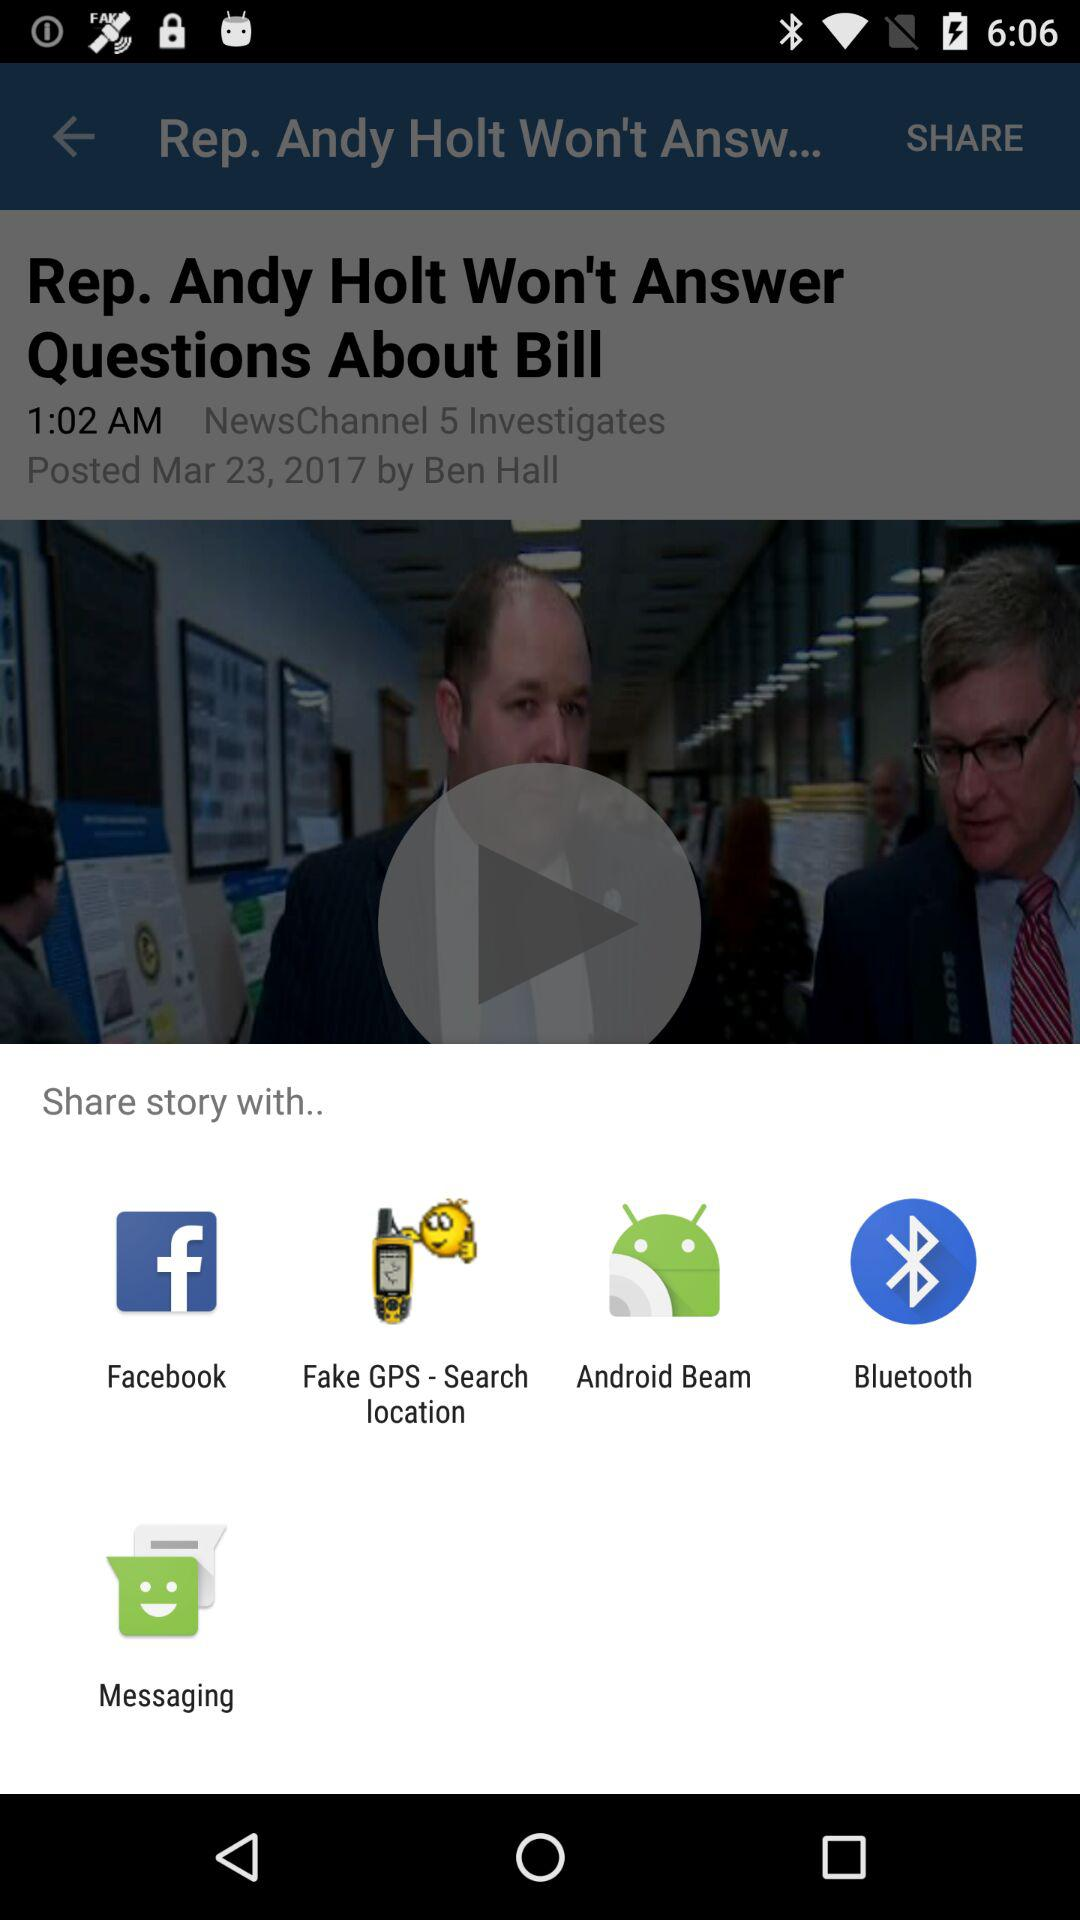Which app can we share with? You can share with "Facebook", "Fake GPS - Search location", "Android Beam", "Bluetooth" and "Messaging". 